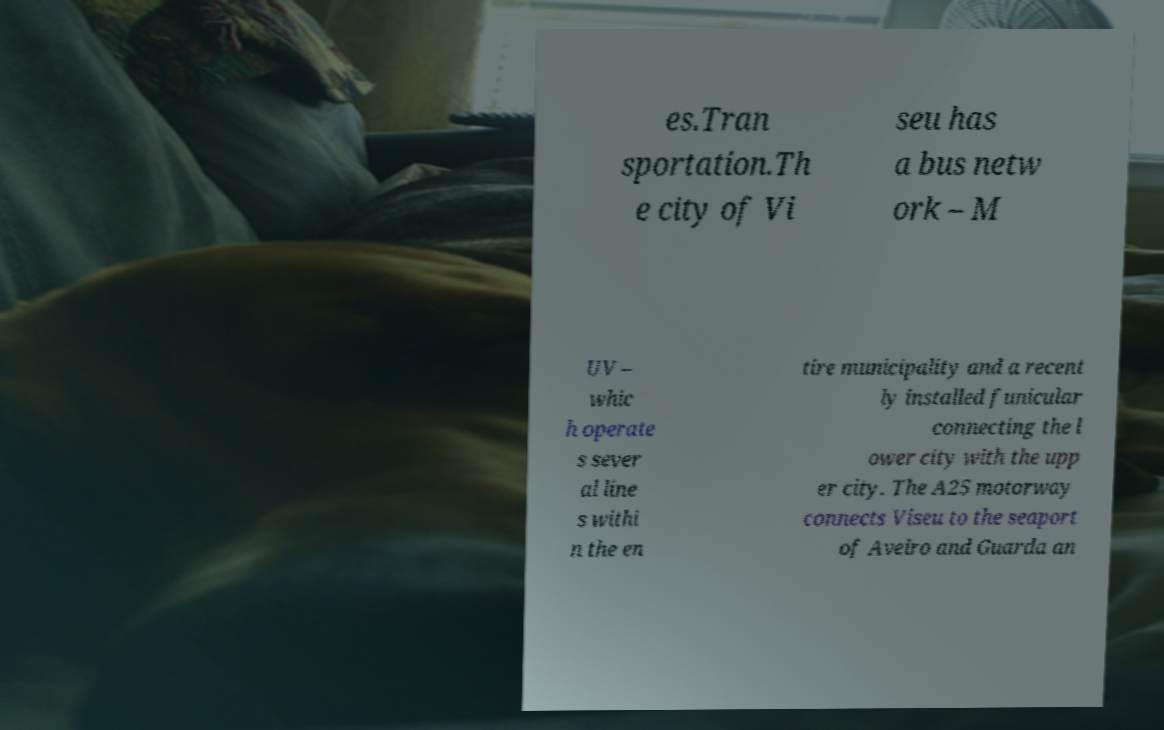I need the written content from this picture converted into text. Can you do that? es.Tran sportation.Th e city of Vi seu has a bus netw ork – M UV – whic h operate s sever al line s withi n the en tire municipality and a recent ly installed funicular connecting the l ower city with the upp er city. The A25 motorway connects Viseu to the seaport of Aveiro and Guarda an 